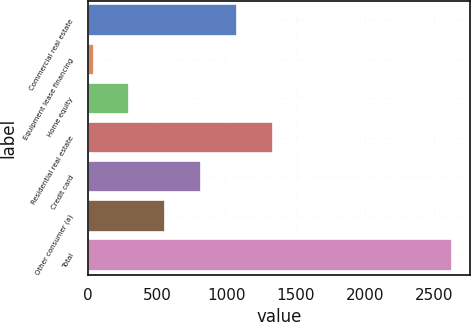Convert chart. <chart><loc_0><loc_0><loc_500><loc_500><bar_chart><fcel>Commercial real estate<fcel>Equipment lease financing<fcel>Home equity<fcel>Residential real estate<fcel>Credit card<fcel>Other consumer (a)<fcel>Total<nl><fcel>1076.8<fcel>42<fcel>300.7<fcel>1335.5<fcel>818.1<fcel>559.4<fcel>2629<nl></chart> 